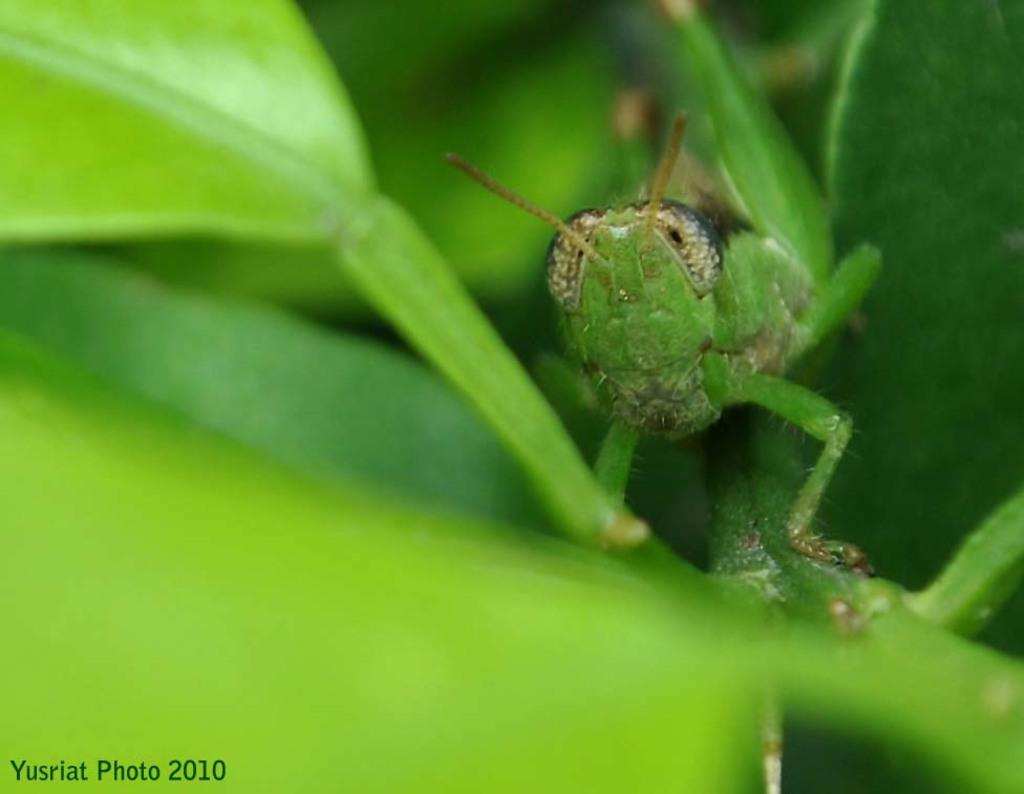What type of creature can be seen in the image? There is an insect in the image. What type of vegetation is present in the image? There are leaves in the image. Can you tell me how many potatoes are visible in the image? There are no potatoes present in the image. What type of horse can be seen in the image? There is no horse present in the image. 